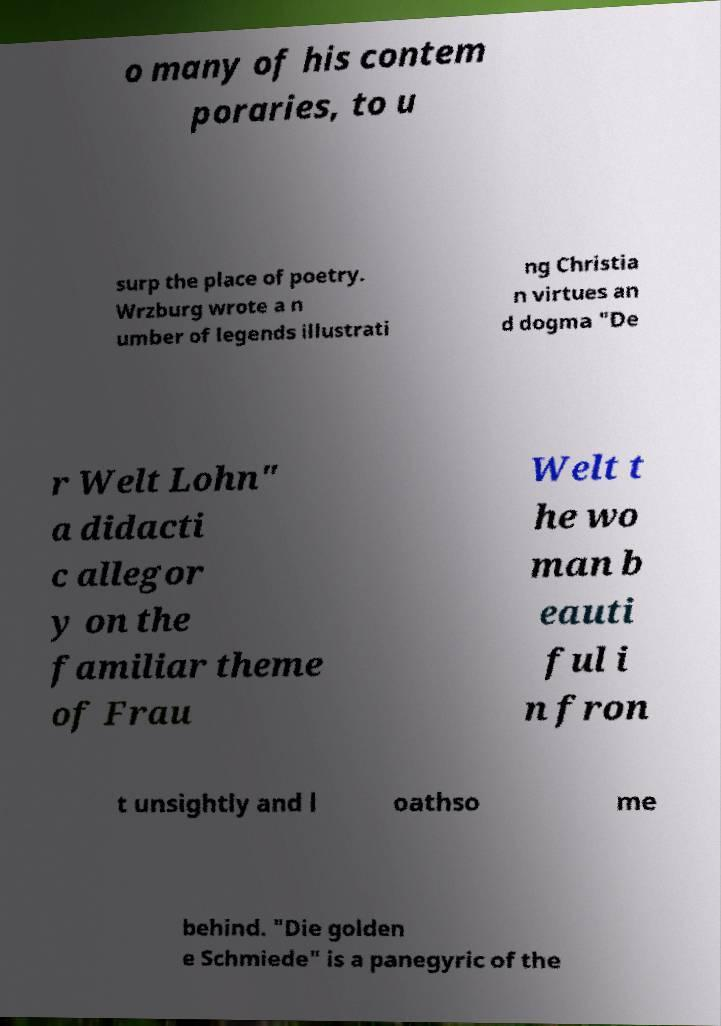For documentation purposes, I need the text within this image transcribed. Could you provide that? o many of his contem poraries, to u surp the place of poetry. Wrzburg wrote a n umber of legends illustrati ng Christia n virtues an d dogma "De r Welt Lohn" a didacti c allegor y on the familiar theme of Frau Welt t he wo man b eauti ful i n fron t unsightly and l oathso me behind. "Die golden e Schmiede" is a panegyric of the 